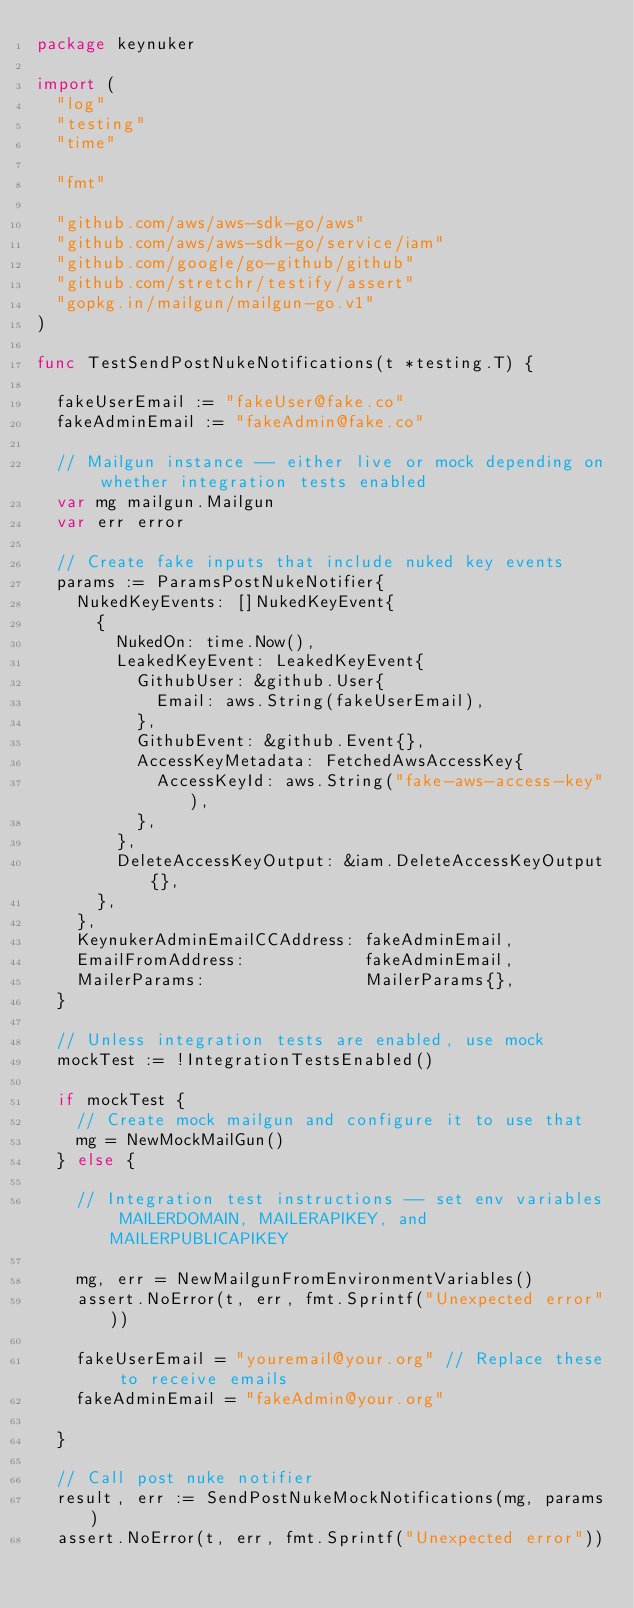Convert code to text. <code><loc_0><loc_0><loc_500><loc_500><_Go_>package keynuker

import (
	"log"
	"testing"
	"time"

	"fmt"

	"github.com/aws/aws-sdk-go/aws"
	"github.com/aws/aws-sdk-go/service/iam"
	"github.com/google/go-github/github"
	"github.com/stretchr/testify/assert"
	"gopkg.in/mailgun/mailgun-go.v1"
)

func TestSendPostNukeNotifications(t *testing.T) {

	fakeUserEmail := "fakeUser@fake.co"
	fakeAdminEmail := "fakeAdmin@fake.co"

	// Mailgun instance -- either live or mock depending on whether integration tests enabled
	var mg mailgun.Mailgun
	var err error

	// Create fake inputs that include nuked key events
	params := ParamsPostNukeNotifier{
		NukedKeyEvents: []NukedKeyEvent{
			{
				NukedOn: time.Now(),
				LeakedKeyEvent: LeakedKeyEvent{
					GithubUser: &github.User{
						Email: aws.String(fakeUserEmail),
					},
					GithubEvent: &github.Event{},
					AccessKeyMetadata: FetchedAwsAccessKey{
						AccessKeyId: aws.String("fake-aws-access-key"),
					},
				},
				DeleteAccessKeyOutput: &iam.DeleteAccessKeyOutput{},
			},
		},
		KeynukerAdminEmailCCAddress: fakeAdminEmail,
		EmailFromAddress:            fakeAdminEmail,
		MailerParams:                MailerParams{},
	}

	// Unless integration tests are enabled, use mock
	mockTest := !IntegrationTestsEnabled()

	if mockTest {
		// Create mock mailgun and configure it to use that
		mg = NewMockMailGun()
	} else {

		// Integration test instructions -- set env variables MAILERDOMAIN, MAILERAPIKEY, and MAILERPUBLICAPIKEY

		mg, err = NewMailgunFromEnvironmentVariables()
		assert.NoError(t, err, fmt.Sprintf("Unexpected error"))

		fakeUserEmail = "youremail@your.org" // Replace these to receive emails
		fakeAdminEmail = "fakeAdmin@your.org"

	}

	// Call post nuke notifier
	result, err := SendPostNukeMockNotifications(mg, params)
	assert.NoError(t, err, fmt.Sprintf("Unexpected error"))
</code> 